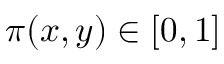Convert formula to latex. <formula><loc_0><loc_0><loc_500><loc_500>\pi ( x , y ) \in [ 0 , 1 ]</formula> 